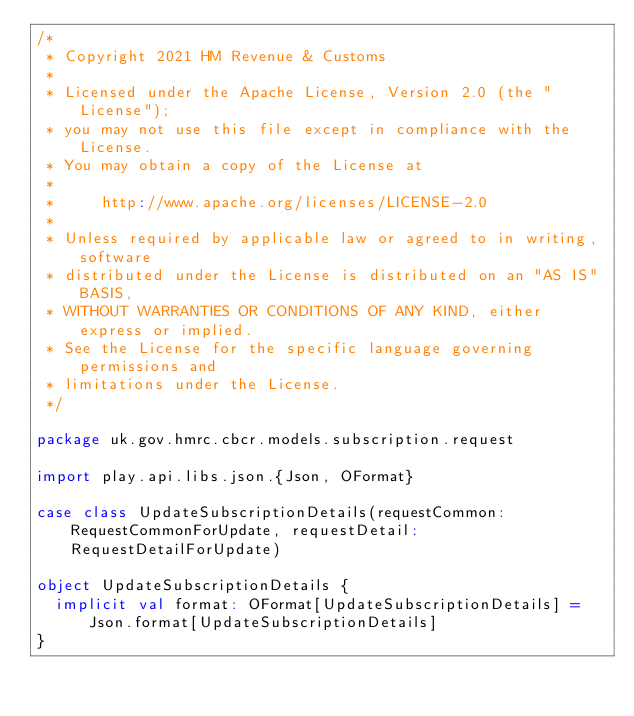Convert code to text. <code><loc_0><loc_0><loc_500><loc_500><_Scala_>/*
 * Copyright 2021 HM Revenue & Customs
 *
 * Licensed under the Apache License, Version 2.0 (the "License");
 * you may not use this file except in compliance with the License.
 * You may obtain a copy of the License at
 *
 *     http://www.apache.org/licenses/LICENSE-2.0
 *
 * Unless required by applicable law or agreed to in writing, software
 * distributed under the License is distributed on an "AS IS" BASIS,
 * WITHOUT WARRANTIES OR CONDITIONS OF ANY KIND, either express or implied.
 * See the License for the specific language governing permissions and
 * limitations under the License.
 */

package uk.gov.hmrc.cbcr.models.subscription.request

import play.api.libs.json.{Json, OFormat}

case class UpdateSubscriptionDetails(requestCommon: RequestCommonForUpdate, requestDetail: RequestDetailForUpdate)

object UpdateSubscriptionDetails {
  implicit val format: OFormat[UpdateSubscriptionDetails] = Json.format[UpdateSubscriptionDetails]
}
</code> 